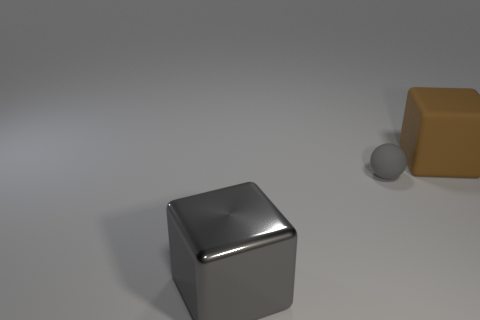If this were a product advertisement, what adjectives could describe these items? These items could be described as sleek, modern, and minimalist. The cleanliness of the lines and the simplicity of the shapes give the items an elegant aesthetic suitable for a contemporary product advertisement. 